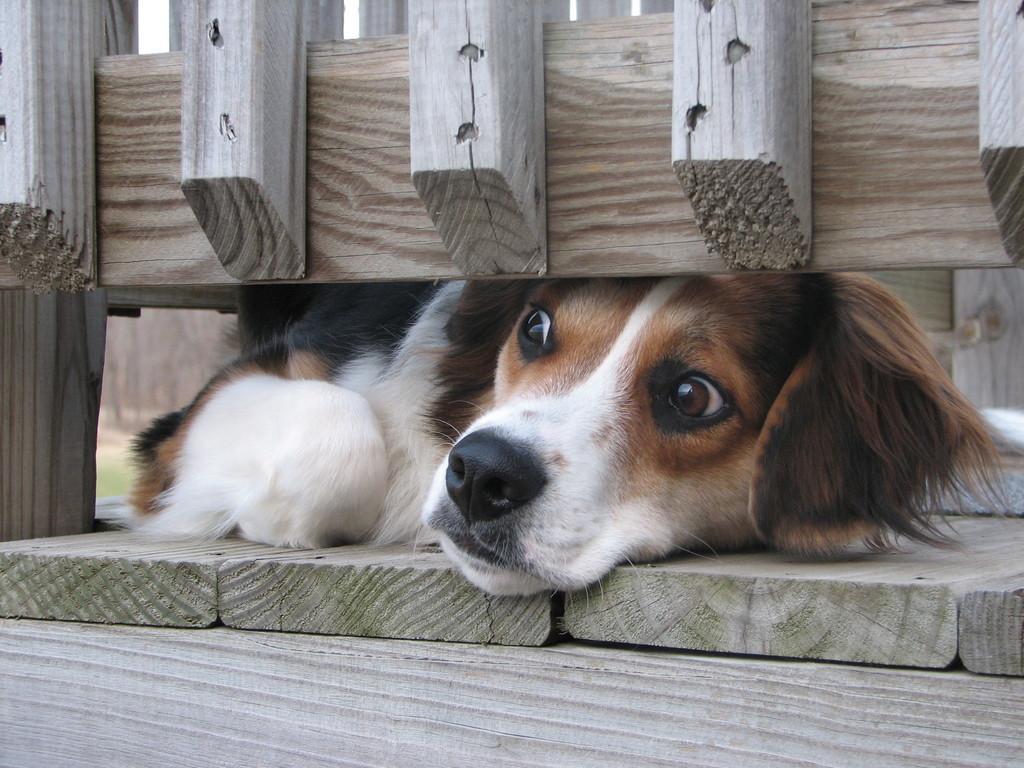How would you summarize this image in a sentence or two? In this image there is a dog lying on a wooden surface. In the foreground, at the top there is a wooden railing. 